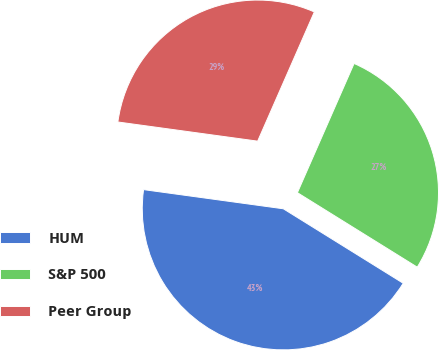Convert chart. <chart><loc_0><loc_0><loc_500><loc_500><pie_chart><fcel>HUM<fcel>S&P 500<fcel>Peer Group<nl><fcel>43.32%<fcel>27.27%<fcel>29.41%<nl></chart> 